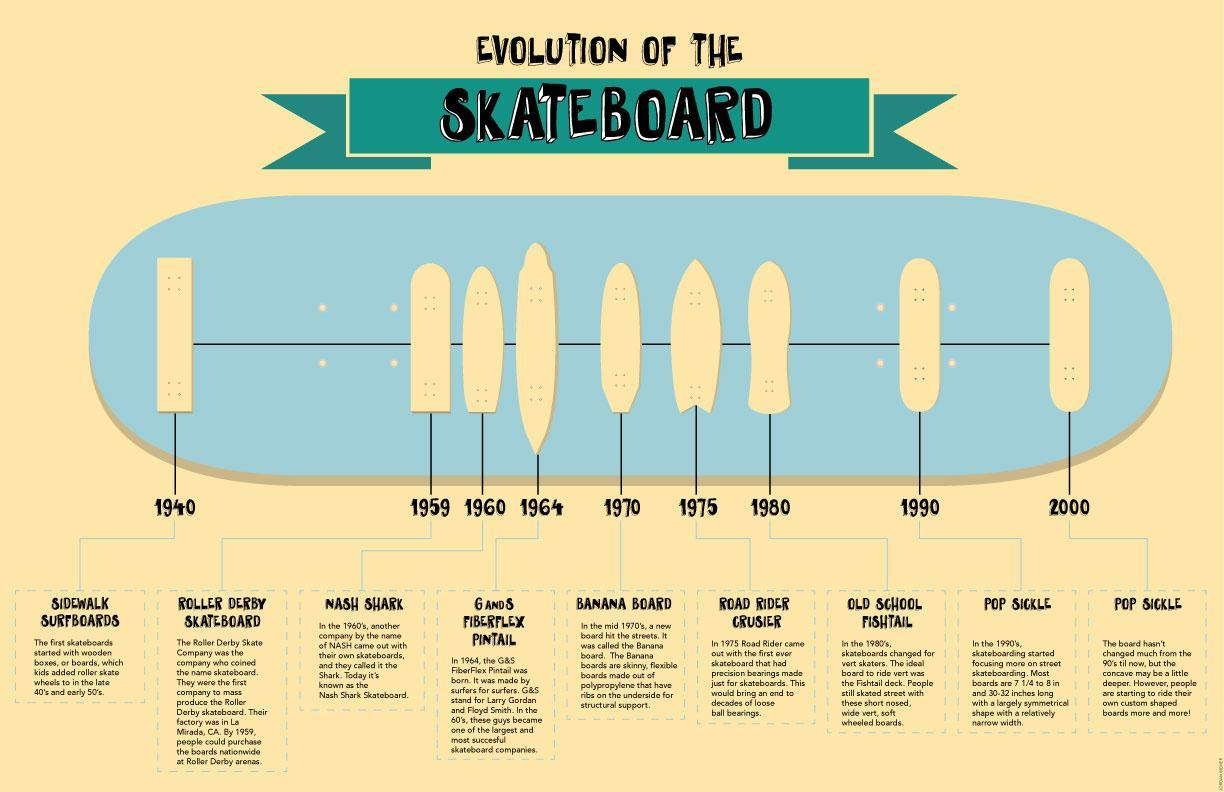what is the colour of all the boards, white or blue?
Answer the question with a short phrase. white How many years did it take after 1990 for the new design 10 in which year was the skateboard the longest 1964 when was the old school fishtail introduced? 1980 when was nash shark introduced? 1960 what was the name of the skateboard with precision bearings road rider crusier What was the name of the board introduced in 1964 G and S Fiberflex Pintail 